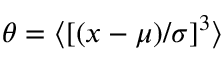Convert formula to latex. <formula><loc_0><loc_0><loc_500><loc_500>\theta = \langle [ ( x - \mu ) / \sigma ] ^ { 3 } \rangle</formula> 